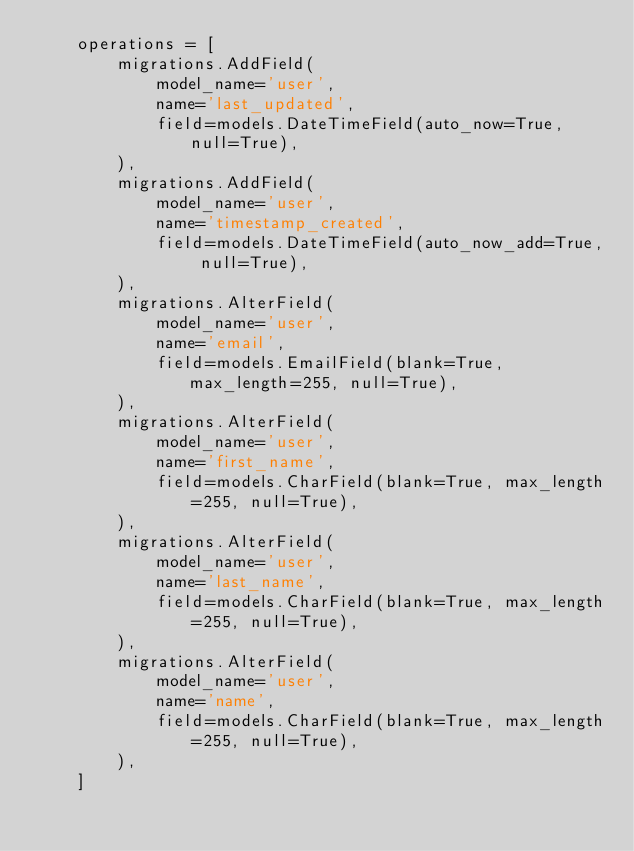Convert code to text. <code><loc_0><loc_0><loc_500><loc_500><_Python_>    operations = [
        migrations.AddField(
            model_name='user',
            name='last_updated',
            field=models.DateTimeField(auto_now=True, null=True),
        ),
        migrations.AddField(
            model_name='user',
            name='timestamp_created',
            field=models.DateTimeField(auto_now_add=True, null=True),
        ),
        migrations.AlterField(
            model_name='user',
            name='email',
            field=models.EmailField(blank=True, max_length=255, null=True),
        ),
        migrations.AlterField(
            model_name='user',
            name='first_name',
            field=models.CharField(blank=True, max_length=255, null=True),
        ),
        migrations.AlterField(
            model_name='user',
            name='last_name',
            field=models.CharField(blank=True, max_length=255, null=True),
        ),
        migrations.AlterField(
            model_name='user',
            name='name',
            field=models.CharField(blank=True, max_length=255, null=True),
        ),
    ]
</code> 